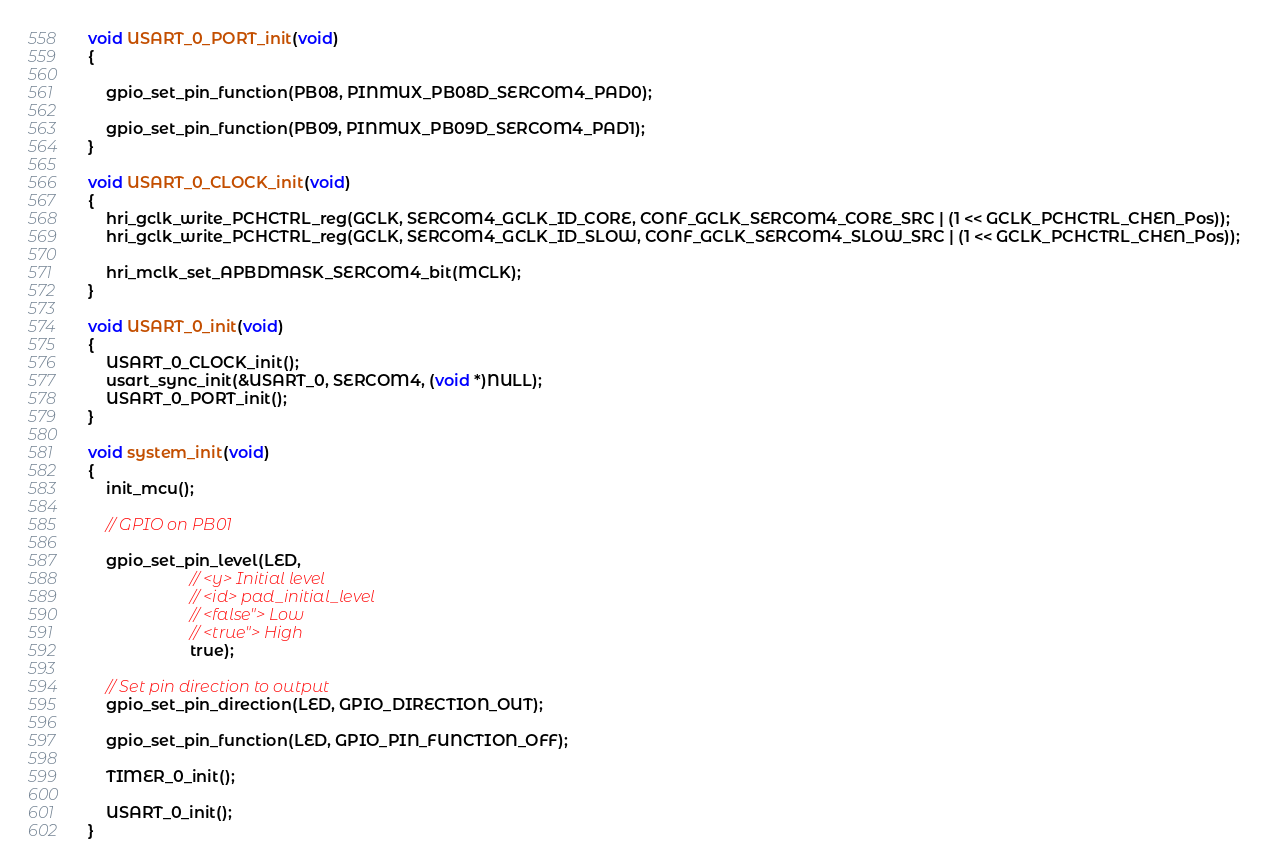Convert code to text. <code><loc_0><loc_0><loc_500><loc_500><_C_>void USART_0_PORT_init(void)
{

	gpio_set_pin_function(PB08, PINMUX_PB08D_SERCOM4_PAD0);

	gpio_set_pin_function(PB09, PINMUX_PB09D_SERCOM4_PAD1);
}

void USART_0_CLOCK_init(void)
{
	hri_gclk_write_PCHCTRL_reg(GCLK, SERCOM4_GCLK_ID_CORE, CONF_GCLK_SERCOM4_CORE_SRC | (1 << GCLK_PCHCTRL_CHEN_Pos));
	hri_gclk_write_PCHCTRL_reg(GCLK, SERCOM4_GCLK_ID_SLOW, CONF_GCLK_SERCOM4_SLOW_SRC | (1 << GCLK_PCHCTRL_CHEN_Pos));

	hri_mclk_set_APBDMASK_SERCOM4_bit(MCLK);
}

void USART_0_init(void)
{
	USART_0_CLOCK_init();
	usart_sync_init(&USART_0, SERCOM4, (void *)NULL);
	USART_0_PORT_init();
}

void system_init(void)
{
	init_mcu();

	// GPIO on PB01

	gpio_set_pin_level(LED,
	                   // <y> Initial level
	                   // <id> pad_initial_level
	                   // <false"> Low
	                   // <true"> High
	                   true);

	// Set pin direction to output
	gpio_set_pin_direction(LED, GPIO_DIRECTION_OUT);

	gpio_set_pin_function(LED, GPIO_PIN_FUNCTION_OFF);

	TIMER_0_init();

	USART_0_init();
}
</code> 